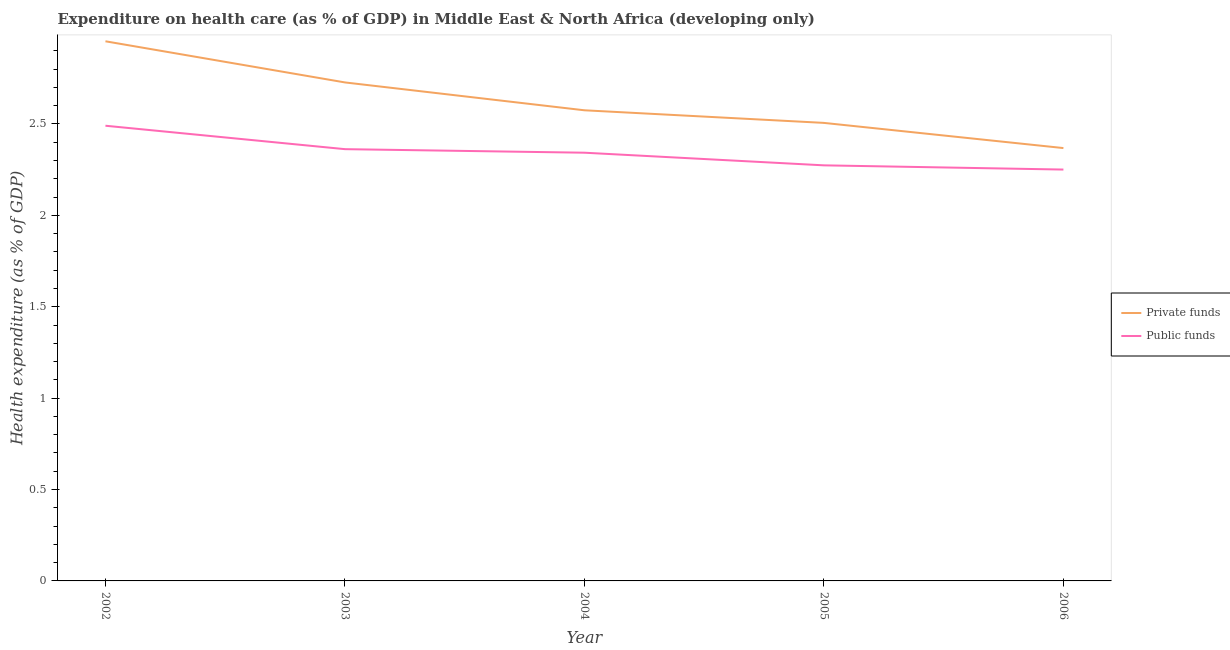What is the amount of private funds spent in healthcare in 2003?
Keep it short and to the point. 2.73. Across all years, what is the maximum amount of private funds spent in healthcare?
Give a very brief answer. 2.95. Across all years, what is the minimum amount of public funds spent in healthcare?
Offer a terse response. 2.25. What is the total amount of private funds spent in healthcare in the graph?
Offer a very short reply. 13.13. What is the difference between the amount of private funds spent in healthcare in 2002 and that in 2003?
Make the answer very short. 0.23. What is the difference between the amount of private funds spent in healthcare in 2003 and the amount of public funds spent in healthcare in 2004?
Make the answer very short. 0.38. What is the average amount of public funds spent in healthcare per year?
Your response must be concise. 2.34. In the year 2005, what is the difference between the amount of public funds spent in healthcare and amount of private funds spent in healthcare?
Offer a very short reply. -0.23. What is the ratio of the amount of private funds spent in healthcare in 2002 to that in 2003?
Your response must be concise. 1.08. Is the difference between the amount of public funds spent in healthcare in 2002 and 2005 greater than the difference between the amount of private funds spent in healthcare in 2002 and 2005?
Give a very brief answer. No. What is the difference between the highest and the second highest amount of public funds spent in healthcare?
Your response must be concise. 0.13. What is the difference between the highest and the lowest amount of private funds spent in healthcare?
Your answer should be compact. 0.58. Is the amount of public funds spent in healthcare strictly less than the amount of private funds spent in healthcare over the years?
Your response must be concise. Yes. How many years are there in the graph?
Ensure brevity in your answer.  5. What is the difference between two consecutive major ticks on the Y-axis?
Give a very brief answer. 0.5. Are the values on the major ticks of Y-axis written in scientific E-notation?
Make the answer very short. No. Does the graph contain grids?
Your answer should be very brief. No. What is the title of the graph?
Provide a short and direct response. Expenditure on health care (as % of GDP) in Middle East & North Africa (developing only). Does "National Tourists" appear as one of the legend labels in the graph?
Give a very brief answer. No. What is the label or title of the Y-axis?
Your response must be concise. Health expenditure (as % of GDP). What is the Health expenditure (as % of GDP) of Private funds in 2002?
Provide a succinct answer. 2.95. What is the Health expenditure (as % of GDP) in Public funds in 2002?
Your answer should be compact. 2.49. What is the Health expenditure (as % of GDP) in Private funds in 2003?
Give a very brief answer. 2.73. What is the Health expenditure (as % of GDP) of Public funds in 2003?
Give a very brief answer. 2.36. What is the Health expenditure (as % of GDP) in Private funds in 2004?
Provide a short and direct response. 2.57. What is the Health expenditure (as % of GDP) of Public funds in 2004?
Provide a short and direct response. 2.34. What is the Health expenditure (as % of GDP) in Private funds in 2005?
Offer a terse response. 2.51. What is the Health expenditure (as % of GDP) in Public funds in 2005?
Keep it short and to the point. 2.27. What is the Health expenditure (as % of GDP) in Private funds in 2006?
Make the answer very short. 2.37. What is the Health expenditure (as % of GDP) in Public funds in 2006?
Your response must be concise. 2.25. Across all years, what is the maximum Health expenditure (as % of GDP) of Private funds?
Offer a very short reply. 2.95. Across all years, what is the maximum Health expenditure (as % of GDP) of Public funds?
Ensure brevity in your answer.  2.49. Across all years, what is the minimum Health expenditure (as % of GDP) in Private funds?
Offer a very short reply. 2.37. Across all years, what is the minimum Health expenditure (as % of GDP) of Public funds?
Keep it short and to the point. 2.25. What is the total Health expenditure (as % of GDP) in Private funds in the graph?
Make the answer very short. 13.13. What is the total Health expenditure (as % of GDP) of Public funds in the graph?
Your response must be concise. 11.72. What is the difference between the Health expenditure (as % of GDP) of Private funds in 2002 and that in 2003?
Give a very brief answer. 0.23. What is the difference between the Health expenditure (as % of GDP) of Public funds in 2002 and that in 2003?
Ensure brevity in your answer.  0.13. What is the difference between the Health expenditure (as % of GDP) in Private funds in 2002 and that in 2004?
Your answer should be compact. 0.38. What is the difference between the Health expenditure (as % of GDP) of Public funds in 2002 and that in 2004?
Make the answer very short. 0.15. What is the difference between the Health expenditure (as % of GDP) of Private funds in 2002 and that in 2005?
Ensure brevity in your answer.  0.45. What is the difference between the Health expenditure (as % of GDP) in Public funds in 2002 and that in 2005?
Your answer should be very brief. 0.22. What is the difference between the Health expenditure (as % of GDP) of Private funds in 2002 and that in 2006?
Offer a very short reply. 0.58. What is the difference between the Health expenditure (as % of GDP) of Public funds in 2002 and that in 2006?
Make the answer very short. 0.24. What is the difference between the Health expenditure (as % of GDP) of Private funds in 2003 and that in 2004?
Your answer should be compact. 0.15. What is the difference between the Health expenditure (as % of GDP) in Public funds in 2003 and that in 2004?
Keep it short and to the point. 0.02. What is the difference between the Health expenditure (as % of GDP) of Private funds in 2003 and that in 2005?
Keep it short and to the point. 0.22. What is the difference between the Health expenditure (as % of GDP) of Public funds in 2003 and that in 2005?
Give a very brief answer. 0.09. What is the difference between the Health expenditure (as % of GDP) of Private funds in 2003 and that in 2006?
Your response must be concise. 0.36. What is the difference between the Health expenditure (as % of GDP) in Public funds in 2003 and that in 2006?
Provide a succinct answer. 0.11. What is the difference between the Health expenditure (as % of GDP) in Private funds in 2004 and that in 2005?
Offer a terse response. 0.07. What is the difference between the Health expenditure (as % of GDP) of Public funds in 2004 and that in 2005?
Provide a short and direct response. 0.07. What is the difference between the Health expenditure (as % of GDP) of Private funds in 2004 and that in 2006?
Offer a terse response. 0.21. What is the difference between the Health expenditure (as % of GDP) in Public funds in 2004 and that in 2006?
Provide a succinct answer. 0.09. What is the difference between the Health expenditure (as % of GDP) of Private funds in 2005 and that in 2006?
Your response must be concise. 0.14. What is the difference between the Health expenditure (as % of GDP) of Public funds in 2005 and that in 2006?
Ensure brevity in your answer.  0.02. What is the difference between the Health expenditure (as % of GDP) in Private funds in 2002 and the Health expenditure (as % of GDP) in Public funds in 2003?
Ensure brevity in your answer.  0.59. What is the difference between the Health expenditure (as % of GDP) of Private funds in 2002 and the Health expenditure (as % of GDP) of Public funds in 2004?
Keep it short and to the point. 0.61. What is the difference between the Health expenditure (as % of GDP) of Private funds in 2002 and the Health expenditure (as % of GDP) of Public funds in 2005?
Provide a short and direct response. 0.68. What is the difference between the Health expenditure (as % of GDP) of Private funds in 2002 and the Health expenditure (as % of GDP) of Public funds in 2006?
Your response must be concise. 0.7. What is the difference between the Health expenditure (as % of GDP) in Private funds in 2003 and the Health expenditure (as % of GDP) in Public funds in 2004?
Your response must be concise. 0.38. What is the difference between the Health expenditure (as % of GDP) in Private funds in 2003 and the Health expenditure (as % of GDP) in Public funds in 2005?
Your answer should be compact. 0.45. What is the difference between the Health expenditure (as % of GDP) in Private funds in 2003 and the Health expenditure (as % of GDP) in Public funds in 2006?
Your answer should be compact. 0.48. What is the difference between the Health expenditure (as % of GDP) of Private funds in 2004 and the Health expenditure (as % of GDP) of Public funds in 2005?
Your answer should be compact. 0.3. What is the difference between the Health expenditure (as % of GDP) in Private funds in 2004 and the Health expenditure (as % of GDP) in Public funds in 2006?
Provide a succinct answer. 0.32. What is the difference between the Health expenditure (as % of GDP) of Private funds in 2005 and the Health expenditure (as % of GDP) of Public funds in 2006?
Offer a terse response. 0.26. What is the average Health expenditure (as % of GDP) in Private funds per year?
Keep it short and to the point. 2.63. What is the average Health expenditure (as % of GDP) of Public funds per year?
Provide a succinct answer. 2.34. In the year 2002, what is the difference between the Health expenditure (as % of GDP) of Private funds and Health expenditure (as % of GDP) of Public funds?
Give a very brief answer. 0.46. In the year 2003, what is the difference between the Health expenditure (as % of GDP) in Private funds and Health expenditure (as % of GDP) in Public funds?
Provide a short and direct response. 0.37. In the year 2004, what is the difference between the Health expenditure (as % of GDP) of Private funds and Health expenditure (as % of GDP) of Public funds?
Your response must be concise. 0.23. In the year 2005, what is the difference between the Health expenditure (as % of GDP) of Private funds and Health expenditure (as % of GDP) of Public funds?
Make the answer very short. 0.23. In the year 2006, what is the difference between the Health expenditure (as % of GDP) in Private funds and Health expenditure (as % of GDP) in Public funds?
Ensure brevity in your answer.  0.12. What is the ratio of the Health expenditure (as % of GDP) of Private funds in 2002 to that in 2003?
Your answer should be very brief. 1.08. What is the ratio of the Health expenditure (as % of GDP) of Public funds in 2002 to that in 2003?
Ensure brevity in your answer.  1.05. What is the ratio of the Health expenditure (as % of GDP) in Private funds in 2002 to that in 2004?
Keep it short and to the point. 1.15. What is the ratio of the Health expenditure (as % of GDP) in Public funds in 2002 to that in 2004?
Provide a short and direct response. 1.06. What is the ratio of the Health expenditure (as % of GDP) in Private funds in 2002 to that in 2005?
Make the answer very short. 1.18. What is the ratio of the Health expenditure (as % of GDP) in Public funds in 2002 to that in 2005?
Your response must be concise. 1.1. What is the ratio of the Health expenditure (as % of GDP) of Private funds in 2002 to that in 2006?
Provide a succinct answer. 1.25. What is the ratio of the Health expenditure (as % of GDP) in Public funds in 2002 to that in 2006?
Make the answer very short. 1.11. What is the ratio of the Health expenditure (as % of GDP) of Private funds in 2003 to that in 2004?
Your answer should be compact. 1.06. What is the ratio of the Health expenditure (as % of GDP) in Public funds in 2003 to that in 2004?
Provide a succinct answer. 1.01. What is the ratio of the Health expenditure (as % of GDP) in Private funds in 2003 to that in 2005?
Provide a succinct answer. 1.09. What is the ratio of the Health expenditure (as % of GDP) in Public funds in 2003 to that in 2005?
Your response must be concise. 1.04. What is the ratio of the Health expenditure (as % of GDP) in Private funds in 2003 to that in 2006?
Make the answer very short. 1.15. What is the ratio of the Health expenditure (as % of GDP) in Public funds in 2003 to that in 2006?
Ensure brevity in your answer.  1.05. What is the ratio of the Health expenditure (as % of GDP) in Private funds in 2004 to that in 2005?
Your answer should be compact. 1.03. What is the ratio of the Health expenditure (as % of GDP) in Public funds in 2004 to that in 2005?
Give a very brief answer. 1.03. What is the ratio of the Health expenditure (as % of GDP) of Private funds in 2004 to that in 2006?
Your response must be concise. 1.09. What is the ratio of the Health expenditure (as % of GDP) of Public funds in 2004 to that in 2006?
Your answer should be compact. 1.04. What is the ratio of the Health expenditure (as % of GDP) of Private funds in 2005 to that in 2006?
Ensure brevity in your answer.  1.06. What is the ratio of the Health expenditure (as % of GDP) of Public funds in 2005 to that in 2006?
Give a very brief answer. 1.01. What is the difference between the highest and the second highest Health expenditure (as % of GDP) of Private funds?
Your answer should be very brief. 0.23. What is the difference between the highest and the second highest Health expenditure (as % of GDP) in Public funds?
Offer a very short reply. 0.13. What is the difference between the highest and the lowest Health expenditure (as % of GDP) of Private funds?
Your answer should be compact. 0.58. What is the difference between the highest and the lowest Health expenditure (as % of GDP) in Public funds?
Your answer should be very brief. 0.24. 